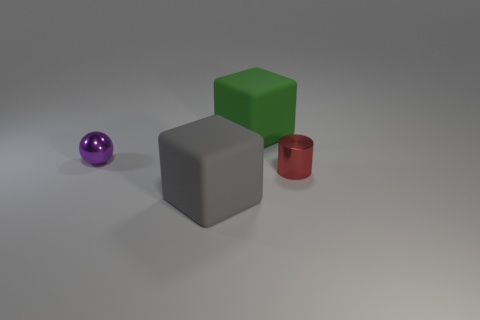Is there anything else that is made of the same material as the large green block?
Offer a very short reply. Yes. Are there more tiny metal cylinders that are left of the large gray thing than big balls?
Make the answer very short. No. Is the color of the tiny cylinder the same as the sphere?
Make the answer very short. No. How many other big rubber things have the same shape as the green thing?
Give a very brief answer. 1. There is a purple ball that is the same material as the tiny cylinder; what is its size?
Give a very brief answer. Small. The thing that is in front of the tiny metallic sphere and behind the large gray cube is what color?
Offer a terse response. Red. What number of other cyan metal spheres have the same size as the metallic ball?
Provide a short and direct response. 0. There is a object that is both behind the gray object and in front of the ball; what is its size?
Ensure brevity in your answer.  Small. How many large blocks are in front of the tiny shiny object left of the big matte object in front of the small red cylinder?
Provide a succinct answer. 1. Is there a tiny metal thing of the same color as the tiny metal cylinder?
Make the answer very short. No. 